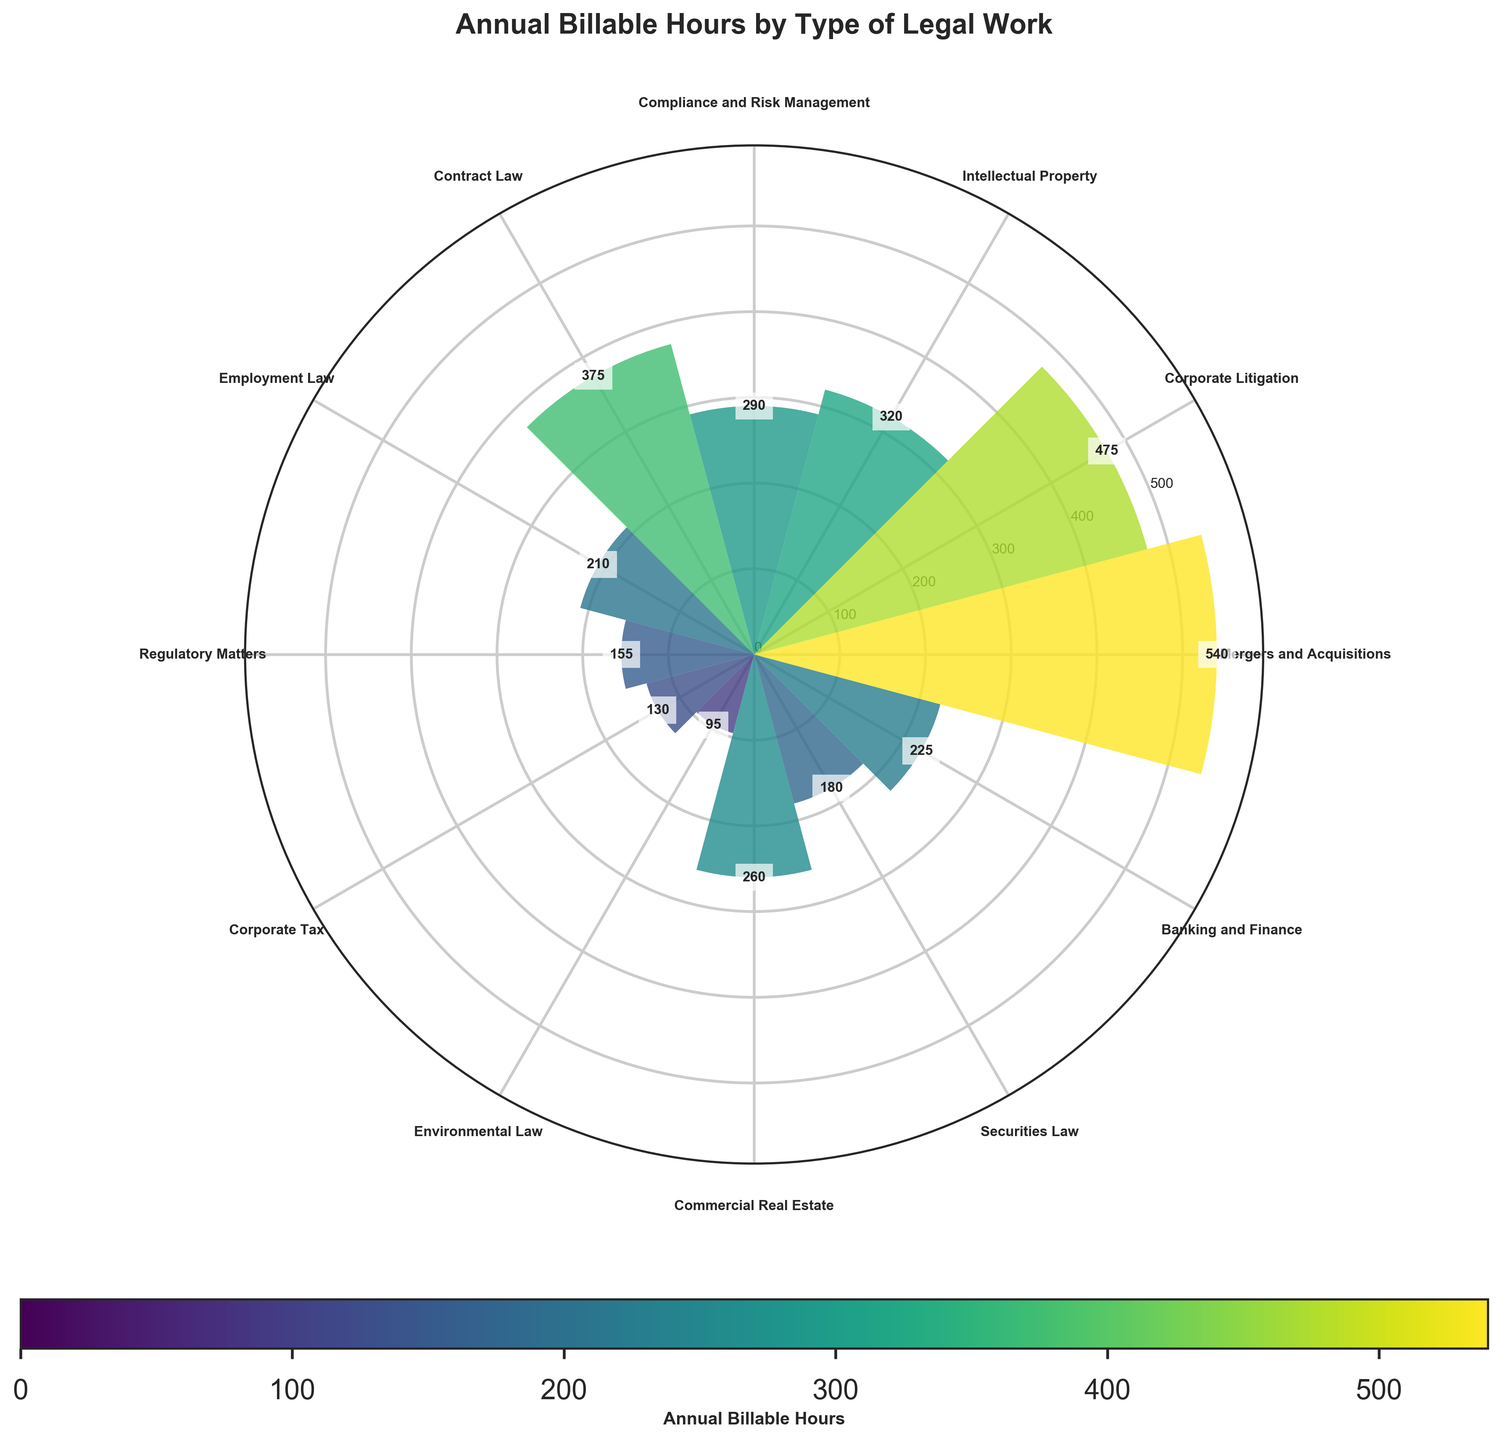What's the title of the figure? The title is usually placed at the top of the figure. In this case, the title reads "Annual Billable Hours by Type of Legal Work".
Answer: Annual Billable Hours by Type of Legal Work Which type of legal work has the highest number of annual billable hours? By observing the heights of the bars, the tallest bar represents Mergers and Acquisitions, with the highest value being 540 hours.
Answer: Mergers and Acquisitions How many types of legal work are represented in the chart? Count the number of bars or labels around the chart. There are 12 different types of legal work displayed in the figure.
Answer: 12 What is the approximate range of annual billable hours for the legal works? The smallest value is the bar corresponding to Environmental Law with 95 hours, and the largest value corresponds to Mergers and Acquisitions with 540 hours. Therefore, the range is 540 - 95.
Answer: 445 hours Which legal work types have annual billable hours greater than 400? By visually inspecting the bars higher than the 400 hours mark, Mergers and Acquisitions (540) and Corporate Litigation (475) are identified.
Answer: Mergers and Acquisitions, Corporate Litigation What is the sum of the annual billable hours for Intellectual Property and Compliance and Risk Management? Add the values for Intellectual Property (320) and Compliance and Risk Management (290). The sum is 320 + 290 = 610 hours.
Answer: 610 hours How do the hours for Contract Law compare to Banking and Finance? Contract Law has 375 hours, and Banking and Finance has 225 hours. 375 is greater than 225.
Answer: Contract Law has more hours than Banking and Finance What is the average number of annual billable hours across all types of legal work? Sum all the hours (540 + 475 + 320 + 290 + 375 + 210 + 155 + 130 + 95 + 260 + 180 + 225) = 3255. Then divide by the number of types (12). 3255 / 12 ≈ 271.25.
Answer: 271.25 hours Which type of legal work has the smallest representation in terms of annual billable hours? The shortest bar in the chart corresponds to Environmental Law with 95 hours.
Answer: Environmental Law Are there any legal work types with annual billable hours less than 200? If so, which ones? Bars below the 200 hours mark include Employment Law (210 close to the mark), Regulatory Matters (155), Corporate Tax (130), Environmental Law (95), and Securities Law (180 closer to the mark).
Answer: Regulatory Matters, Corporate Tax, Environmental Law, Securities Law 